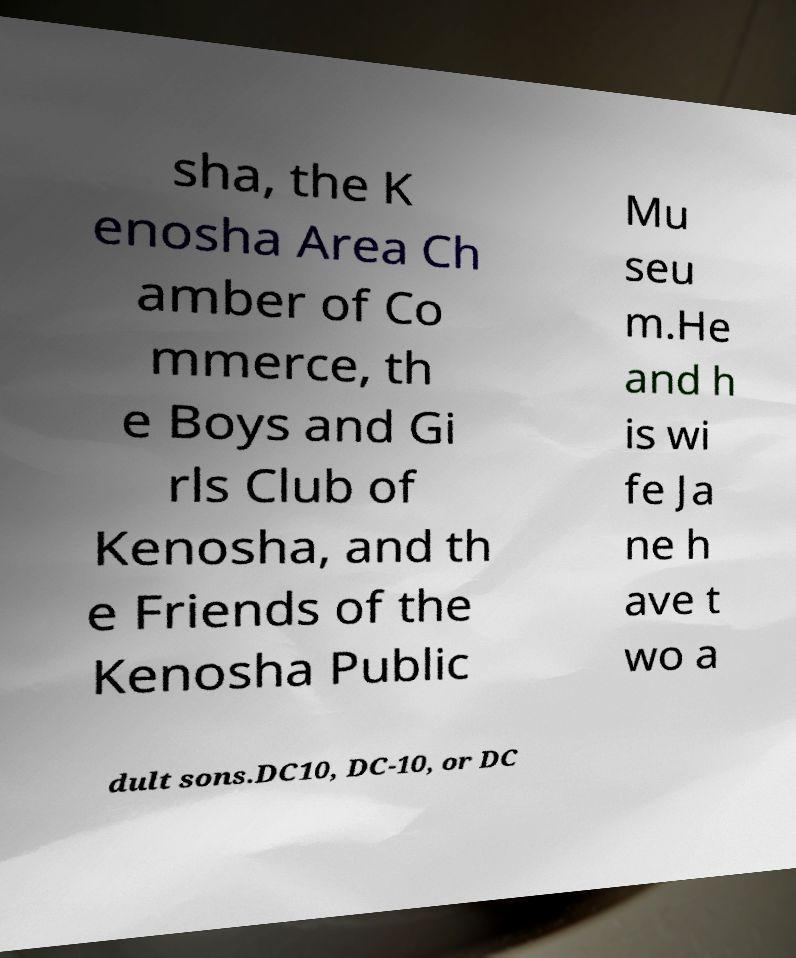Please identify and transcribe the text found in this image. sha, the K enosha Area Ch amber of Co mmerce, th e Boys and Gi rls Club of Kenosha, and th e Friends of the Kenosha Public Mu seu m.He and h is wi fe Ja ne h ave t wo a dult sons.DC10, DC-10, or DC 